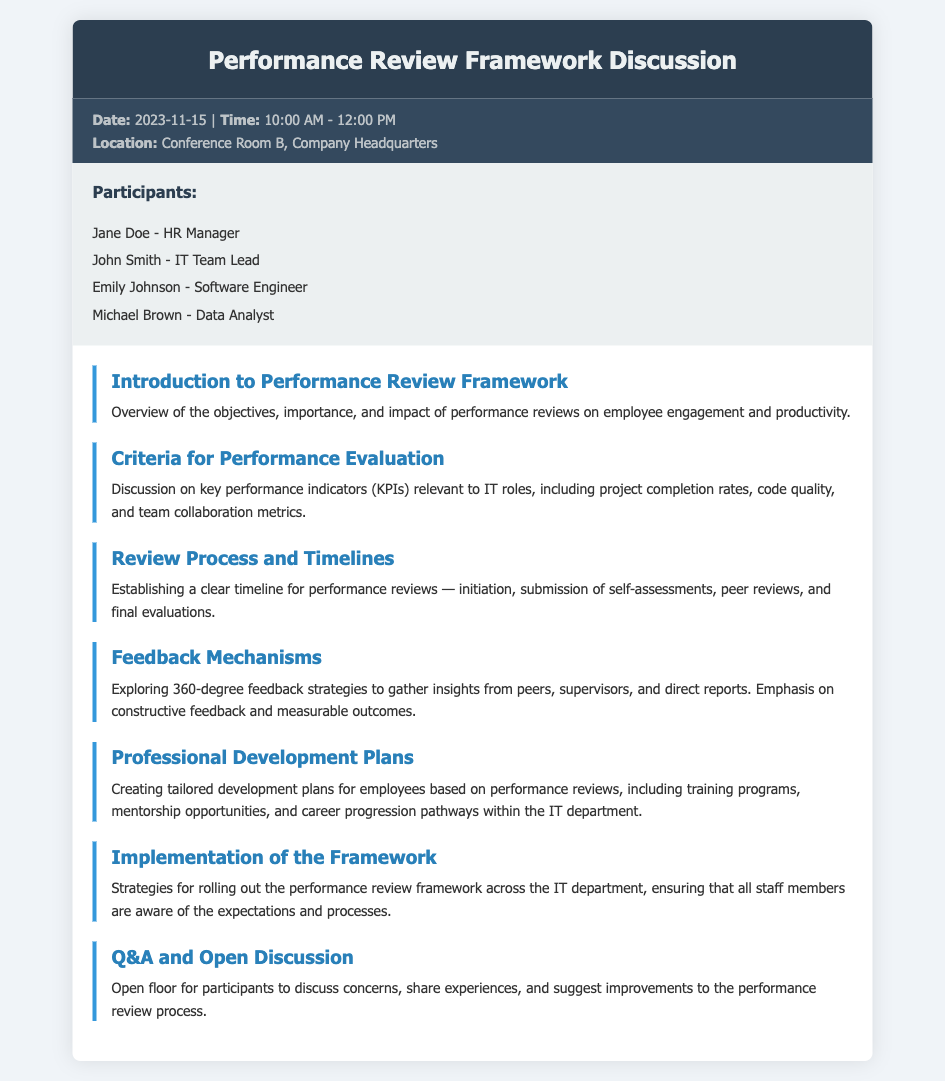What is the date of the Performance Review Framework Discussion? The date is mentioned in the meta-info section of the document.
Answer: 2023-11-15 Who is the HR Manager participating in the discussion? The name of the HR Manager is listed in the participants section.
Answer: Jane Doe What is the location of the meeting? The location is specified in the meta-info section.
Answer: Conference Room B, Company Headquarters What is discussed under the “Criteria for Performance Evaluation”? This section outlines the key performance indicators relevant to IT roles.
Answer: Key performance indicators (KPIs) What is the main focus of the “Feedback Mechanisms” agenda item? This agenda item covers strategies for gathering insights from various sources.
Answer: 360-degree feedback strategies What should be created for employees based on performance reviews? This item emphasizes the necessity of tailored plans for staff development.
Answer: Professional Development Plans How long is the scheduled meeting? The duration of the meeting is indicated in the meta-info section.
Answer: 2 hours Which agenda item suggests improvements to the performance review process? The open discussion is aimed at addressing this concern.
Answer: Q&A and Open Discussion 